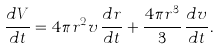Convert formula to latex. <formula><loc_0><loc_0><loc_500><loc_500>\frac { d V } { d t } = 4 \pi r ^ { 2 } v \, \frac { d r } { d t } + \frac { 4 \pi r ^ { 3 } } { 3 } \, \frac { d v } { d t } .</formula> 